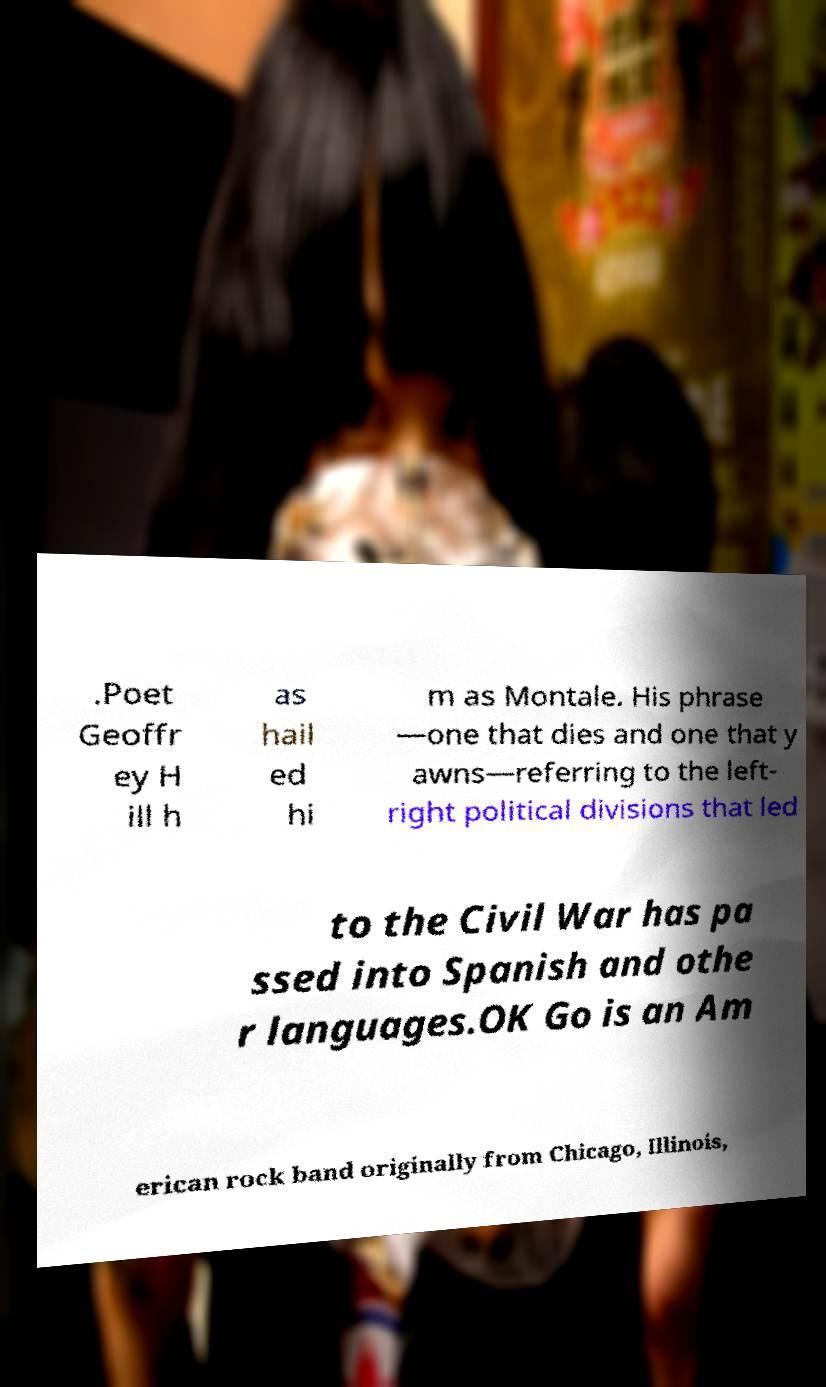For documentation purposes, I need the text within this image transcribed. Could you provide that? .Poet Geoffr ey H ill h as hail ed hi m as Montale. His phrase —one that dies and one that y awns—referring to the left- right political divisions that led to the Civil War has pa ssed into Spanish and othe r languages.OK Go is an Am erican rock band originally from Chicago, Illinois, 